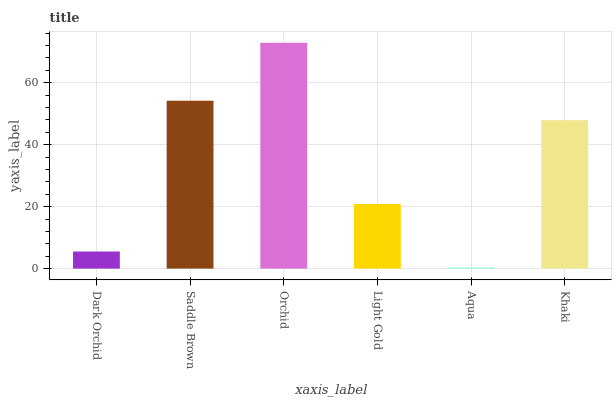Is Aqua the minimum?
Answer yes or no. Yes. Is Orchid the maximum?
Answer yes or no. Yes. Is Saddle Brown the minimum?
Answer yes or no. No. Is Saddle Brown the maximum?
Answer yes or no. No. Is Saddle Brown greater than Dark Orchid?
Answer yes or no. Yes. Is Dark Orchid less than Saddle Brown?
Answer yes or no. Yes. Is Dark Orchid greater than Saddle Brown?
Answer yes or no. No. Is Saddle Brown less than Dark Orchid?
Answer yes or no. No. Is Khaki the high median?
Answer yes or no. Yes. Is Light Gold the low median?
Answer yes or no. Yes. Is Saddle Brown the high median?
Answer yes or no. No. Is Dark Orchid the low median?
Answer yes or no. No. 